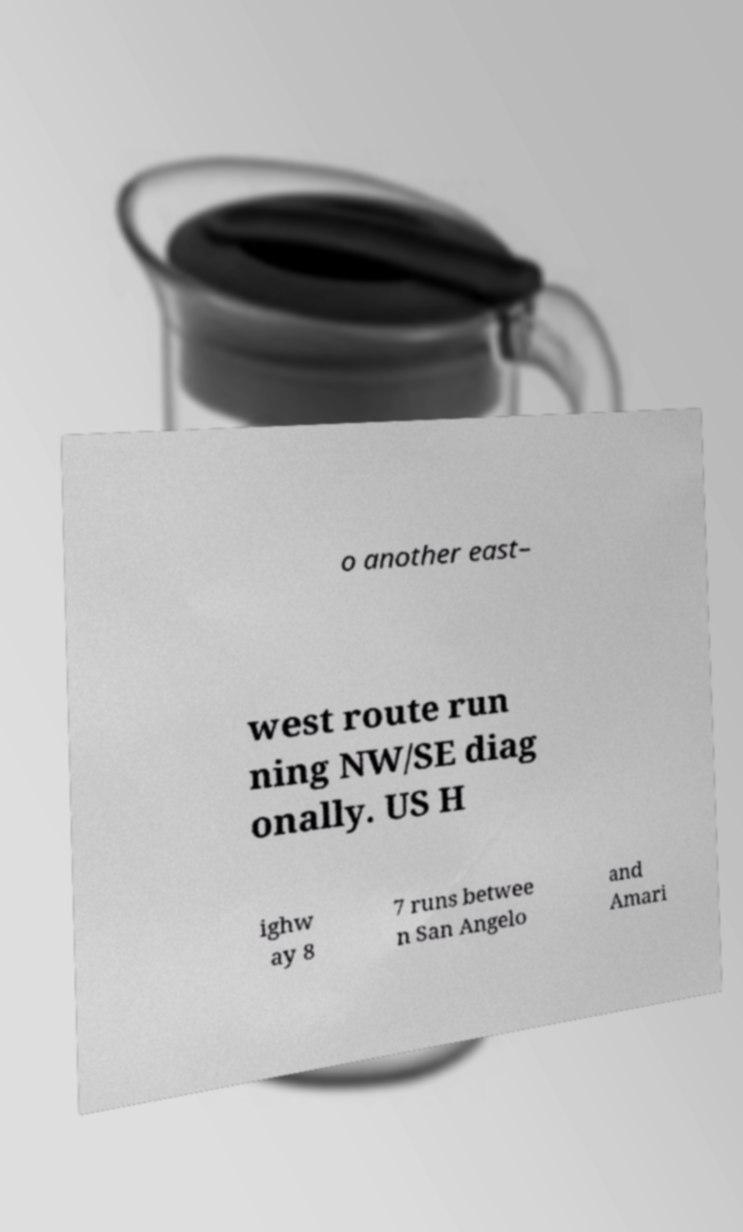What messages or text are displayed in this image? I need them in a readable, typed format. o another east– west route run ning NW/SE diag onally. US H ighw ay 8 7 runs betwee n San Angelo and Amari 